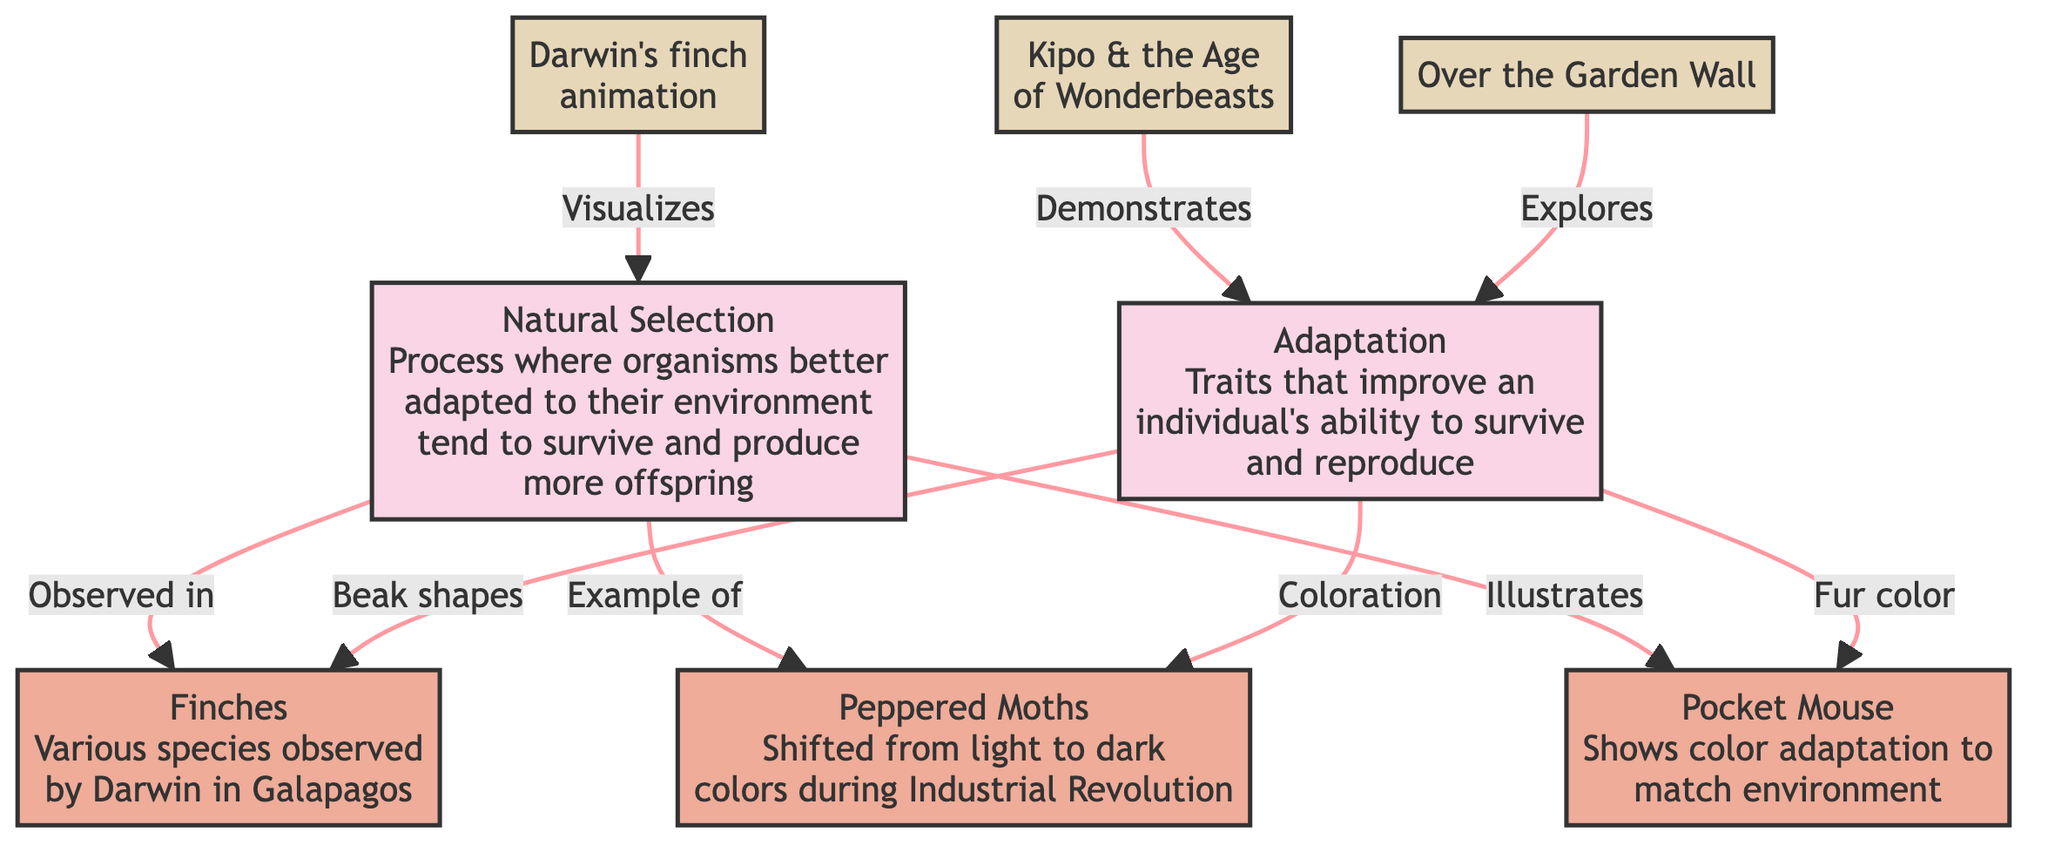What is the process depicted in the diagram? The diagram depicts "Natural Selection," described as a process where organisms better adapted to their environment tend to survive and produce more offspring.
Answer: Natural Selection How many species are mentioned in the diagram? There are three species represented in the diagram: Finches, Peppered Moths, and Pocket Mouse.
Answer: 3 What adaptation is associated with the finches? The adaptation associated with the finches is "Beak shapes," which improve their ability to survive and reproduce in their environment.
Answer: Beak shapes Which example illustrates natural selection? The example that illustrates natural selection is "Darwin's finch animation," demonstrating the concept through visual representation.
Answer: Darwin's finch animation What coloration change did the Peppered Moths undergo? The Peppered Moths changed from "light to dark" colors during the Industrial Revolution as an adaptation to their environment.
Answer: Light to dark What demonstrates the concept of adaptation in the animated series? The animated series "Kipo & the Age of Wonderbeasts" demonstrates the concept of adaptation, showcasing how characters or creatures adapt to their surroundings.
Answer: Kipo & the Age of Wonderbeasts What does the Pocket Mouse show adaptation to? The Pocket Mouse shows color adaptation to "match environment," specifically regarding its fur color, improving its chances of survival.
Answer: Match environment Which species is a direct example of color adaptation? The species that is a direct example of color adaptation is "Peppered Moths," which shifted their coloration based on the environmental changes due to industrialization.
Answer: Peppered Moths What concludes the relationship between adaptation and the three species? The relationship concludes that each species has distinct adaptations: beak shapes for finches, coloration for moths, and fur color for mice, all crucial for survival in their respective environments.
Answer: Distinct adaptations 